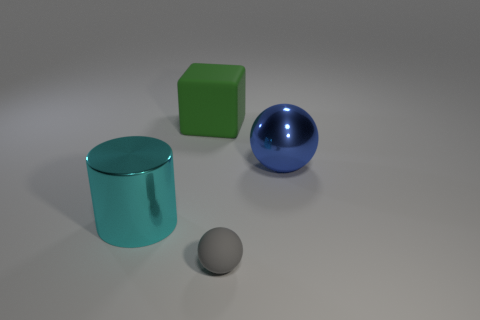Add 2 big brown things. How many objects exist? 6 Subtract all blocks. How many objects are left? 3 Add 2 large shiny cubes. How many large shiny cubes exist? 2 Subtract 0 yellow cylinders. How many objects are left? 4 Subtract all blue matte balls. Subtract all tiny objects. How many objects are left? 3 Add 2 cubes. How many cubes are left? 3 